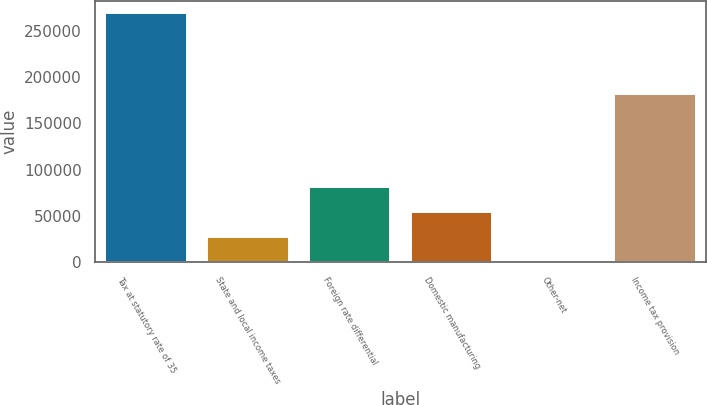Convert chart to OTSL. <chart><loc_0><loc_0><loc_500><loc_500><bar_chart><fcel>Tax at statutory rate of 35<fcel>State and local income taxes<fcel>Foreign rate differential<fcel>Domestic manufacturing<fcel>Other-net<fcel>Income tax provision<nl><fcel>268841<fcel>27541.1<fcel>81163.3<fcel>54352.2<fcel>730<fcel>181702<nl></chart> 